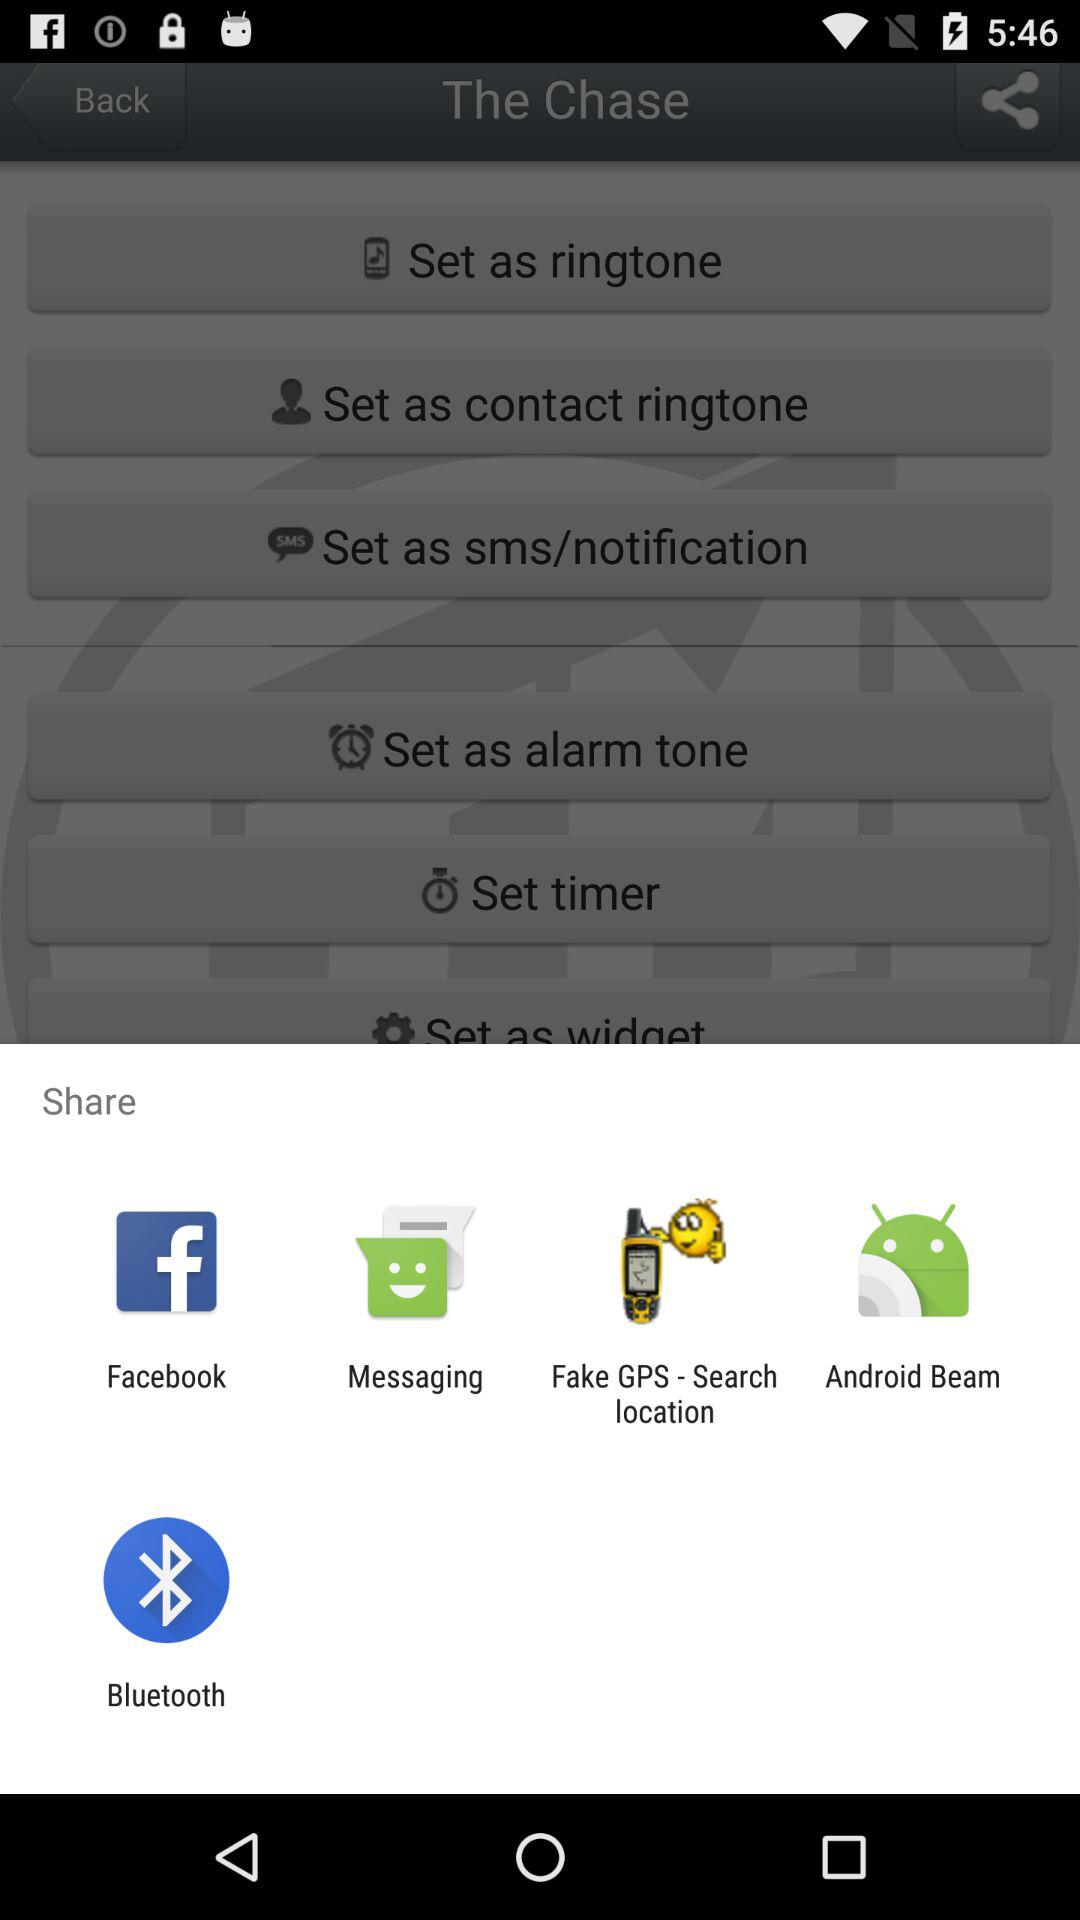What application can I use for sharing the content? You can share it with "Facebook", "Messaging", "Fake GPS - Search location", "Android Beam" and "Bluetooth". 